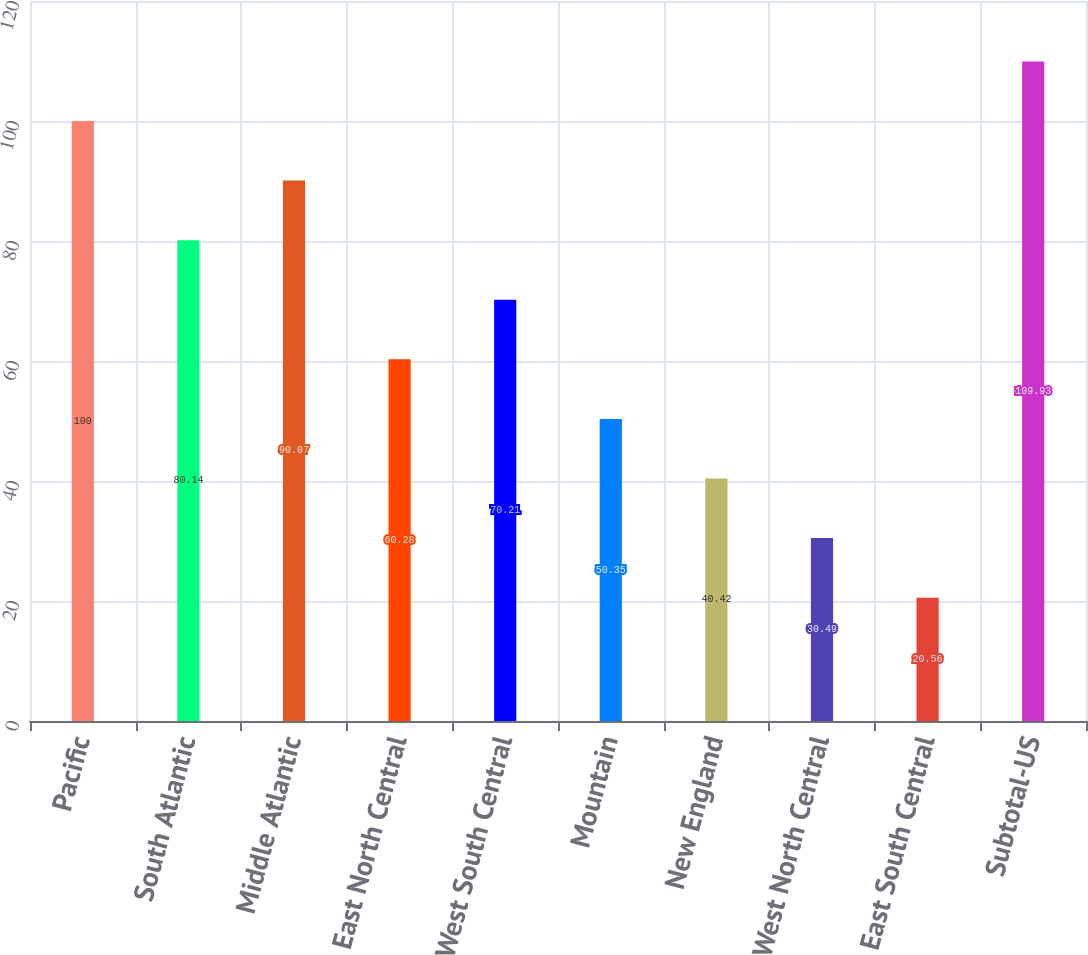<chart> <loc_0><loc_0><loc_500><loc_500><bar_chart><fcel>Pacific<fcel>South Atlantic<fcel>Middle Atlantic<fcel>East North Central<fcel>West South Central<fcel>Mountain<fcel>New England<fcel>West North Central<fcel>East South Central<fcel>Subtotal-US<nl><fcel>100<fcel>80.14<fcel>90.07<fcel>60.28<fcel>70.21<fcel>50.35<fcel>40.42<fcel>30.49<fcel>20.56<fcel>109.93<nl></chart> 